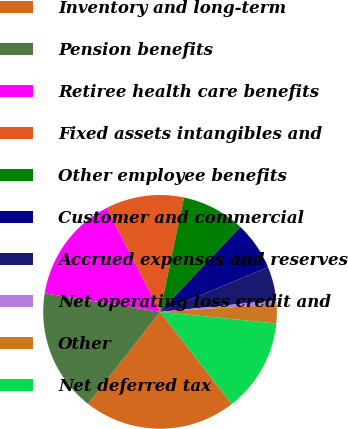Convert chart. <chart><loc_0><loc_0><loc_500><loc_500><pie_chart><fcel>Inventory and long-term<fcel>Pension benefits<fcel>Retiree health care benefits<fcel>Fixed assets intangibles and<fcel>Other employee benefits<fcel>Customer and commercial<fcel>Accrued expenses and reserves<fcel>Net operating loss credit and<fcel>Other<fcel>Net deferred tax<nl><fcel>21.09%<fcel>16.98%<fcel>14.93%<fcel>10.82%<fcel>8.77%<fcel>6.71%<fcel>4.66%<fcel>0.55%<fcel>2.61%<fcel>12.88%<nl></chart> 